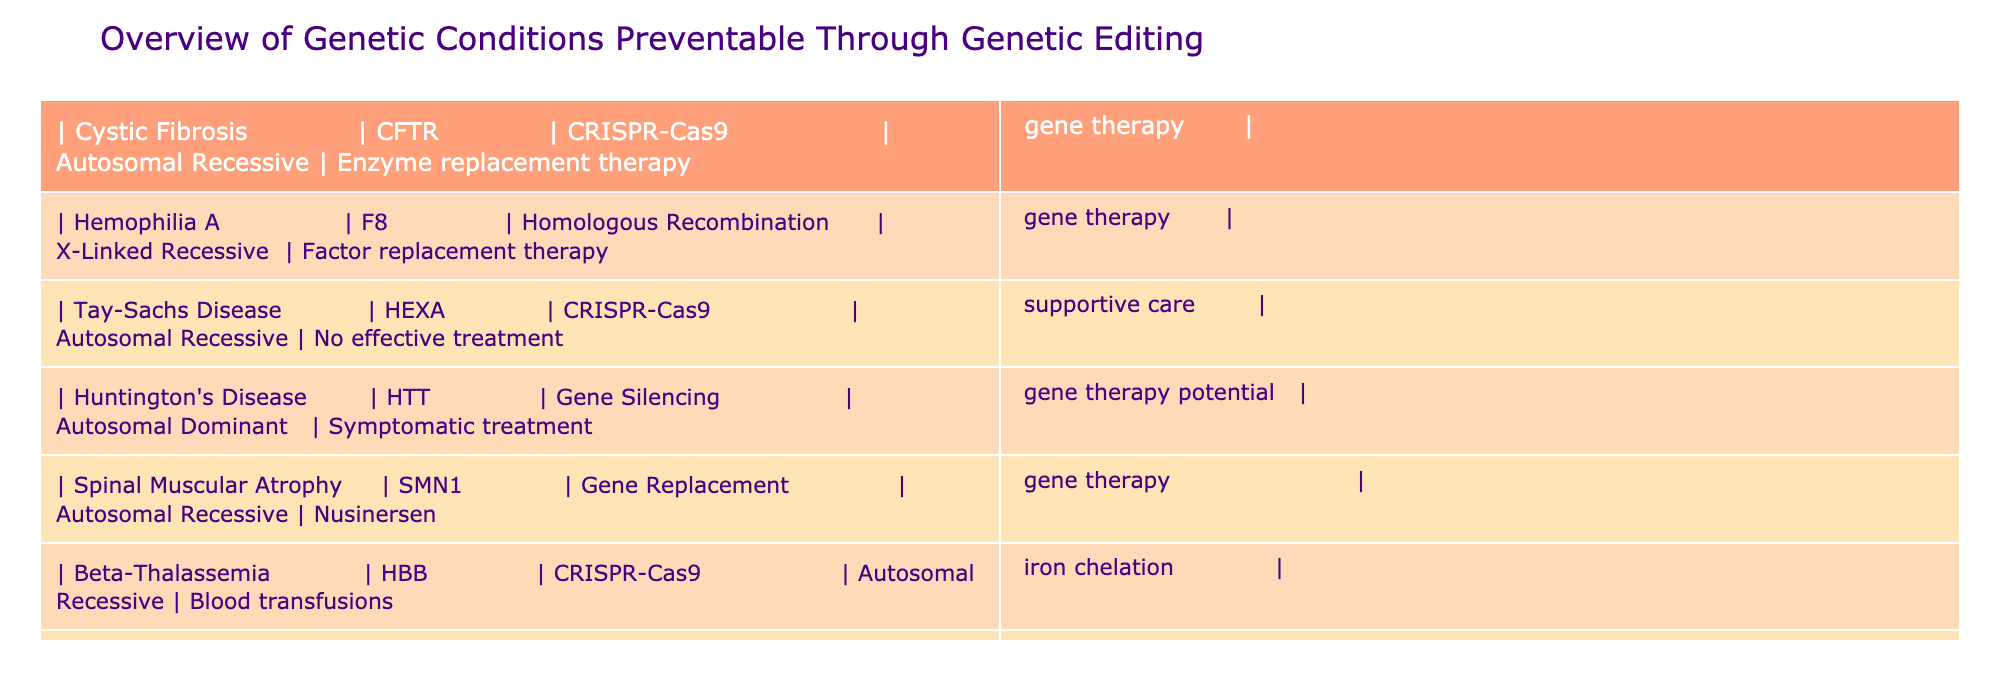What genetic condition is associated with the CFTR gene? The table lists Cystic Fibrosis as the genetic condition associated with the CFTR gene.
Answer: Cystic Fibrosis Which genetic editing technology is used to prevent Tay-Sachs Disease? The table indicates that CRISPR-Cas9 is the genetic editing technology used to prevent Tay-Sachs Disease.
Answer: CRISPR-Cas9 How many conditions can be treated with enzyme replacement therapy? From the table, the conditions that can be treated with enzyme replacement therapy are Cystic Fibrosis and Phenylketonuria, totaling two conditions.
Answer: 2 Is Hemophilia A preventable through genetic editing? Yes, the table shows that Hemophilia A can be treated using homologous recombination genetic editing.
Answer: Yes What is the common treatment option for conditions caused by autosomal recessive genes listed in the table? Among the conditions caused by autosomal recessive genes, common treatments include enzyme replacement therapy and gene therapy, which are mentioned in the cases of Cystic Fibrosis, Tay-Sachs Disease, Spinal Muscular Atrophy, Beta-Thalassemia, and Phenylketonuria.
Answer: Enzyme replacement therapy and gene therapy What percentage of the listed conditions use CRISPR-Cas9 as a genetic editing technology? There are 7 conditions listed, and 4 of them (Cystic Fibrosis, Tay-Sachs Disease, Beta-Thalassemia, and Hemophilia A) use CRISPR-Cas9. Thus, the percentage is (4/7) * 100 = approximately 57.14%.
Answer: 57.14% Which genetic condition has no effective treatment other than supportive care? The table specifies that Tay-Sachs Disease has no effective treatment other than supportive care.
Answer: Tay-Sachs Disease What distinguishes Huntington's Disease regarding its inheritance pattern? Huntington's Disease is classified as an autosomal dominant condition, differing from the others listed, which are primarily autosomal recessive or X-linked recessive conditions.
Answer: Autosomal dominant Which condition requires blood transfusions as part of its treatment? The table states that Beta-Thalassemia requires blood transfusions as one of its treatment options.
Answer: Beta-Thalassemia 